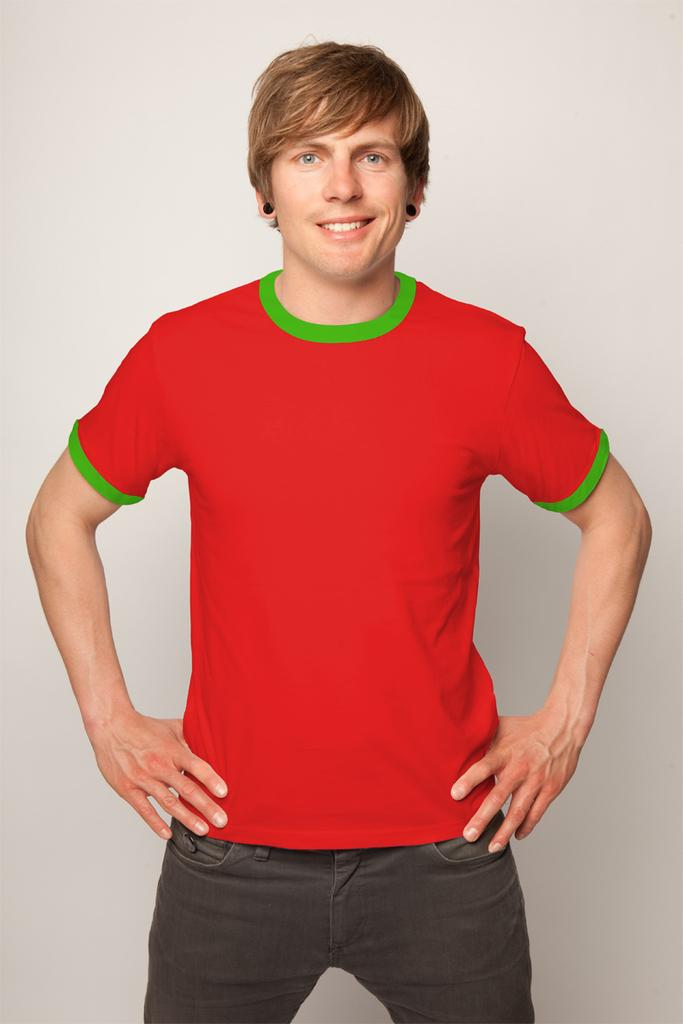What is the main subject of the image? There is a man in the image. What is the man wearing? The man is wearing a red t-shirt. What expression does the man have? The man is smiling. What color is the background of the image? The background of the image is white. What time of day is it in the image, and is there a rabbit present? The time of day is not mentioned in the image, and there is no rabbit present. 